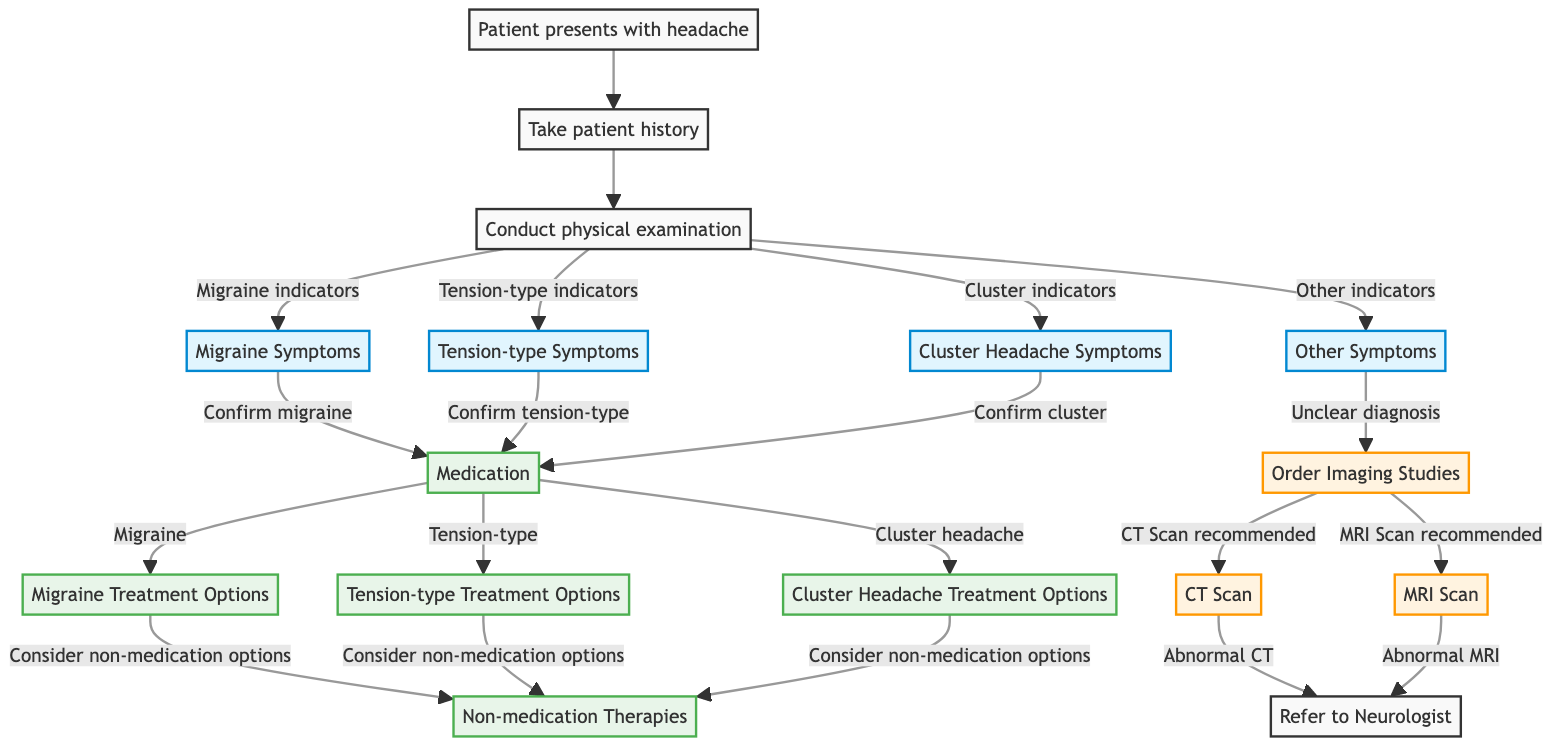What is the starting point of the workflow? The diagram begins with the node labeled "Patient presents with headache," which indicates the initial step in the diagnosis process.
Answer: Patient presents with headache How many types of headache symptoms are identified in the diagram? The diagram identifies four types of headache symptoms: Migraine Symptoms, Tension-type Symptoms, Cluster Headache Symptoms, and Other Symptoms. Counting these gives a total of four.
Answer: 4 What is the action taken if the physical examination indicates 'Other Symptoms'? If 'Other Symptoms' are indicated, the next action is to "Order Imaging Studies," reflecting the need for additional tests to clarify the diagnosis.
Answer: Order Imaging Studies Which imaging study follows if a CT Scan is ordered? If a CT Scan is ordered and the result is abnormal, the next action will be to "Refer to Neurologist," indicating a need for specialist evaluation based on the imaging results.
Answer: Refer to Neurologist What are the three treatment options available for migraines? The treatment options for migraines listed in the diagram include "Migraine Treatment Options," "Consider non-medication options," and the initial step of "Medication."
Answer: Migraine Treatment Options If a patient confirms having tension-type headache symptoms, what is the next step? Once tension-type symptoms are confirmed, the patient moves directly to the "Medication" node, where treatment options will be discussed, indicating that medication is the next step in the workflow.
Answer: Medication Which nodes indicate a referral to a specialist? The nodes that indicate a referral to a specialist are "Refer to Neurologist," which follows from abnormal results of either the CT Scan or MRI Scan, highlighting the pathway for complex cases.
Answer: Refer to Neurologist What therapeutic options are available for patients diagnosed with cluster headaches? For patients diagnosed with cluster headaches, the available option is "Cluster Headache Treatment Options," which reflects the specific therapeutic pathways tailored for this type of headache.
Answer: Cluster Headache Treatment Options 